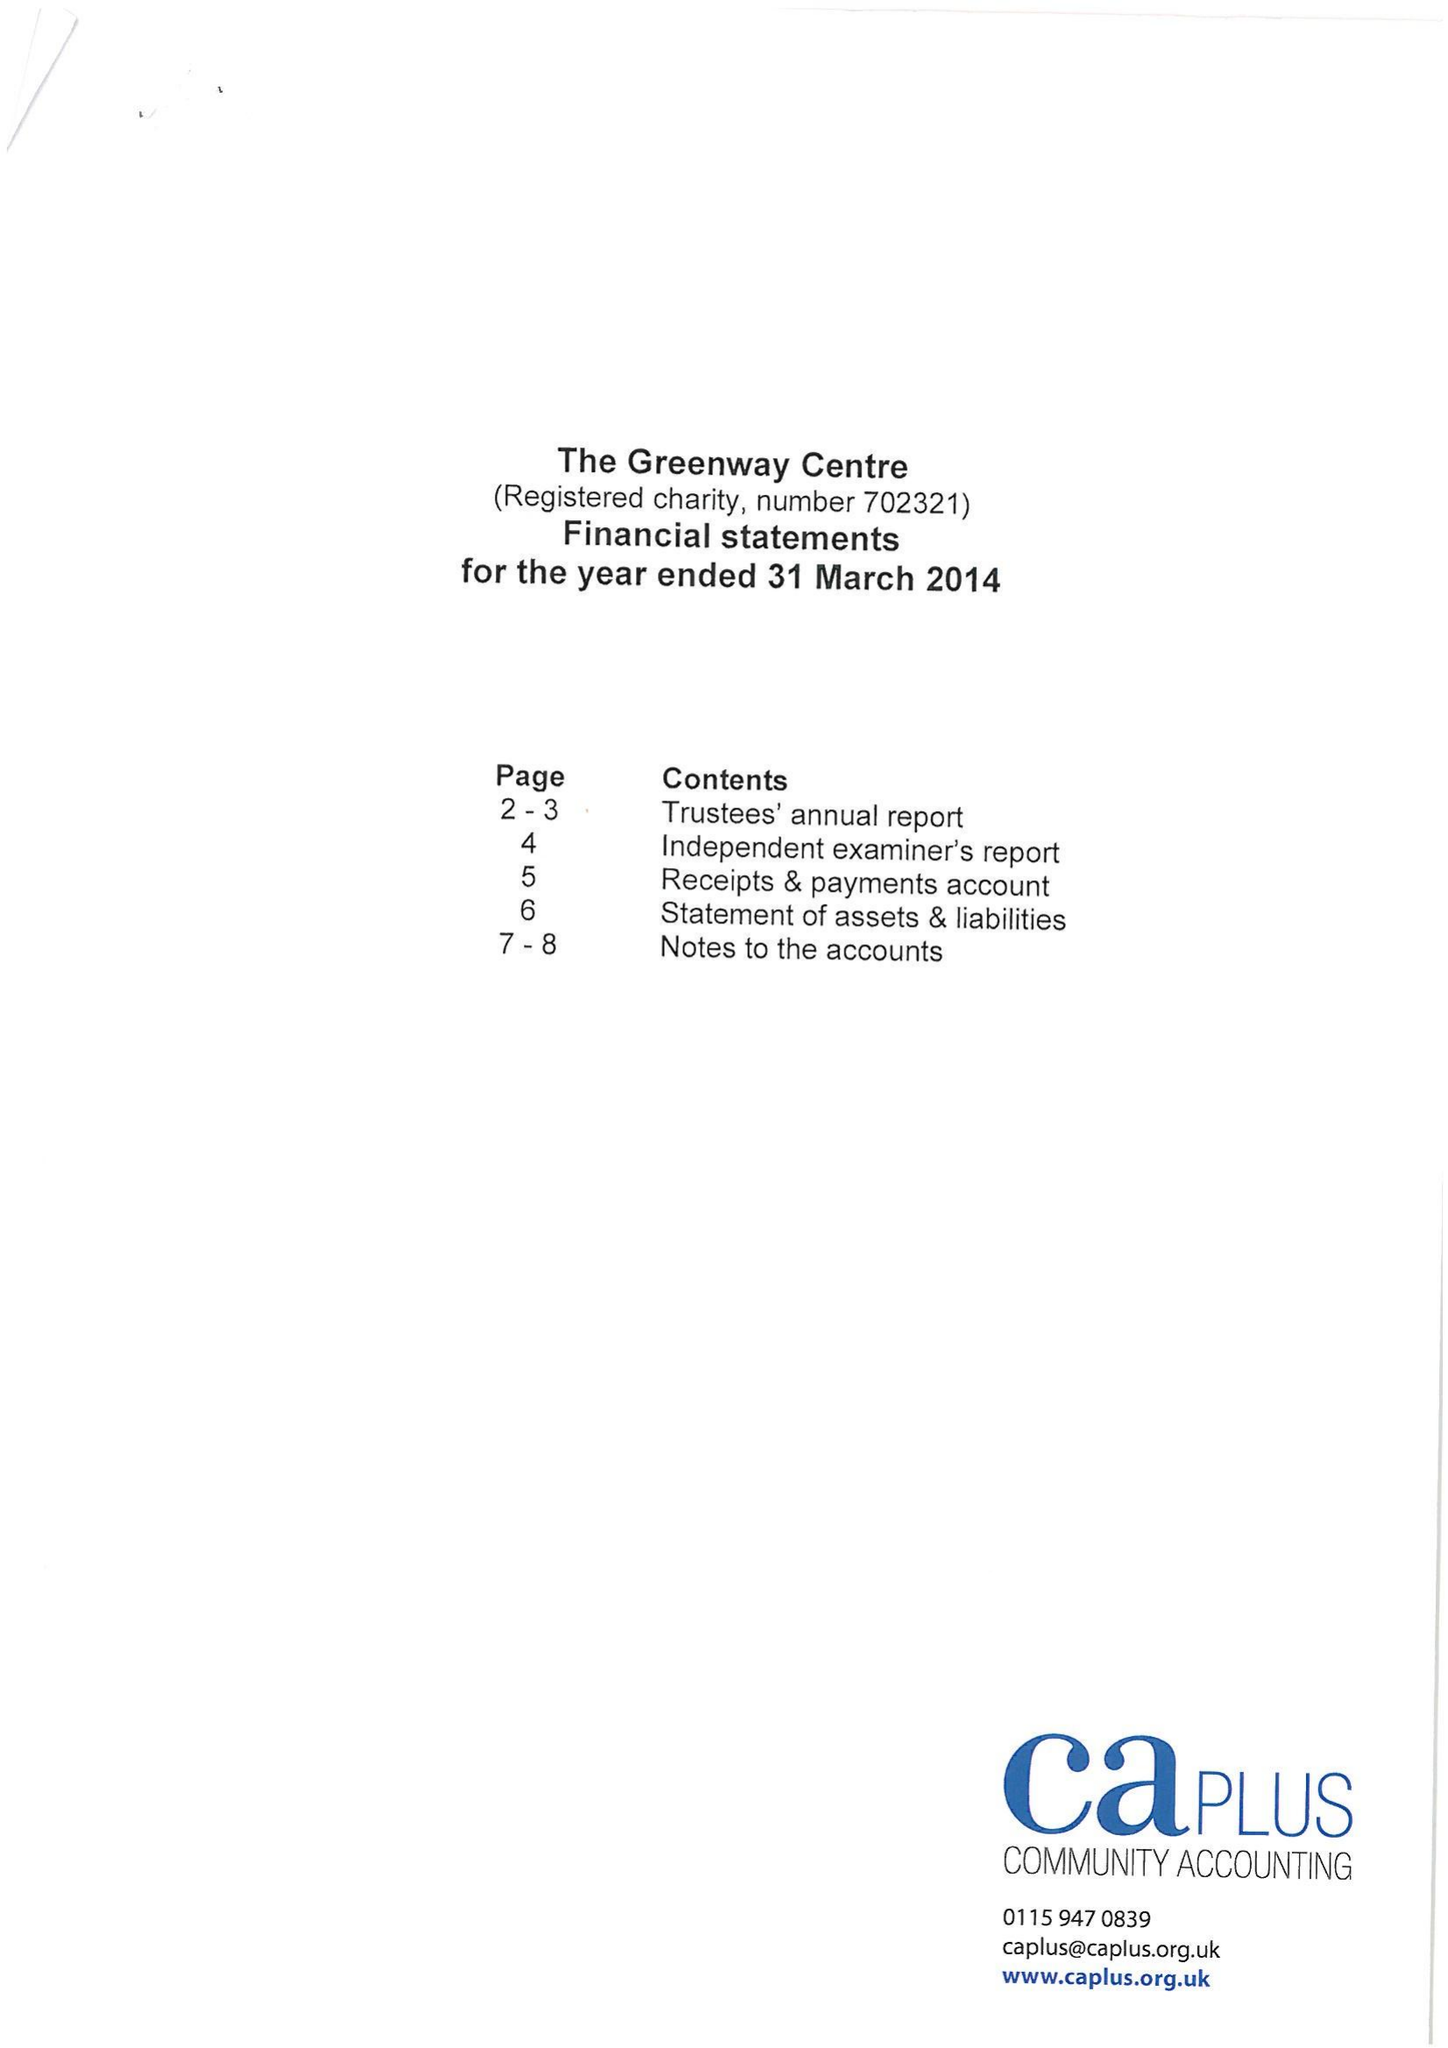What is the value for the spending_annually_in_british_pounds?
Answer the question using a single word or phrase. 93109.00 